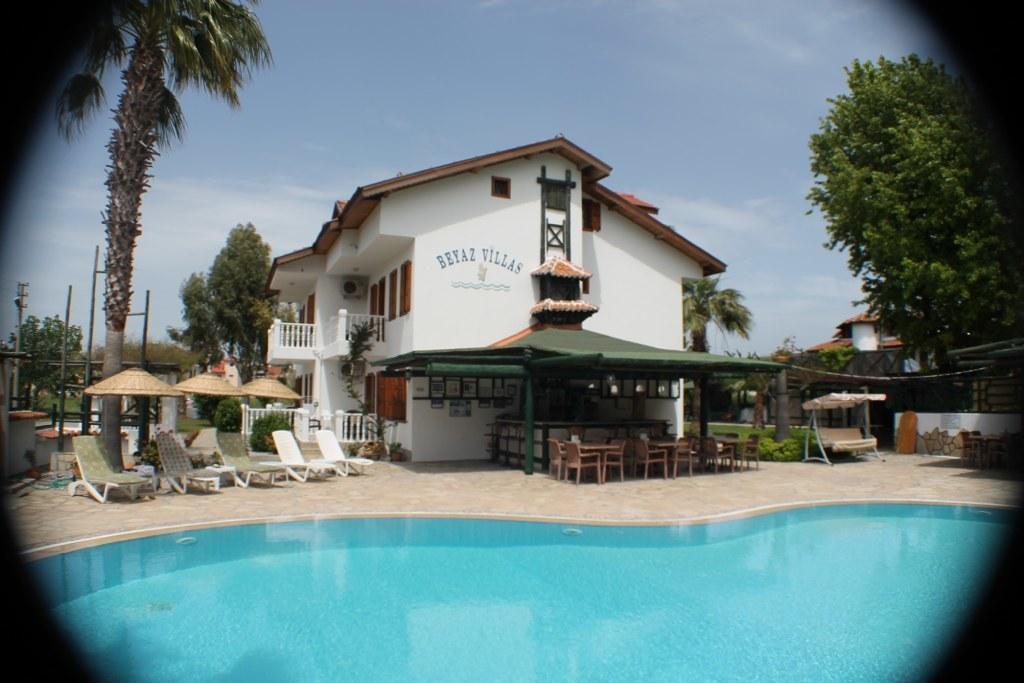Can you describe this image briefly? In the picture we can see a photograph of a swimming pool with water and behind it, we can see a path to it, we can see some chairs and some umbrellas on it and beside it, we can see a house with some windows and doors and inside the house we can see some furniture and on the other sides of the house we can see trees and in the background we can see a sky with clouds. 